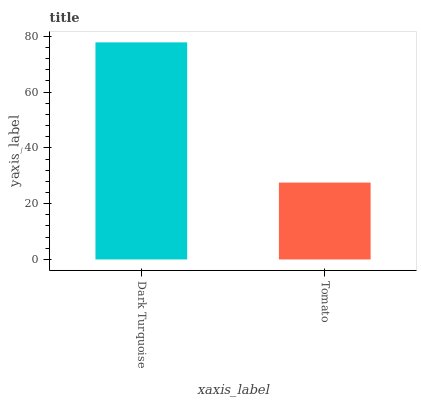Is Tomato the minimum?
Answer yes or no. Yes. Is Dark Turquoise the maximum?
Answer yes or no. Yes. Is Tomato the maximum?
Answer yes or no. No. Is Dark Turquoise greater than Tomato?
Answer yes or no. Yes. Is Tomato less than Dark Turquoise?
Answer yes or no. Yes. Is Tomato greater than Dark Turquoise?
Answer yes or no. No. Is Dark Turquoise less than Tomato?
Answer yes or no. No. Is Dark Turquoise the high median?
Answer yes or no. Yes. Is Tomato the low median?
Answer yes or no. Yes. Is Tomato the high median?
Answer yes or no. No. Is Dark Turquoise the low median?
Answer yes or no. No. 